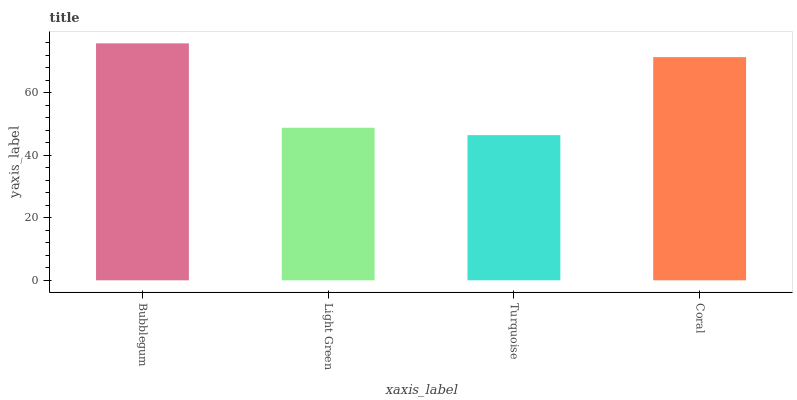Is Turquoise the minimum?
Answer yes or no. Yes. Is Bubblegum the maximum?
Answer yes or no. Yes. Is Light Green the minimum?
Answer yes or no. No. Is Light Green the maximum?
Answer yes or no. No. Is Bubblegum greater than Light Green?
Answer yes or no. Yes. Is Light Green less than Bubblegum?
Answer yes or no. Yes. Is Light Green greater than Bubblegum?
Answer yes or no. No. Is Bubblegum less than Light Green?
Answer yes or no. No. Is Coral the high median?
Answer yes or no. Yes. Is Light Green the low median?
Answer yes or no. Yes. Is Turquoise the high median?
Answer yes or no. No. Is Coral the low median?
Answer yes or no. No. 